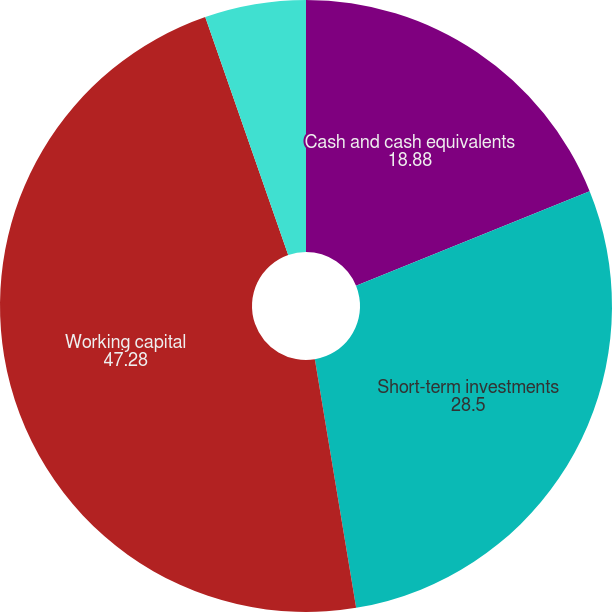Convert chart. <chart><loc_0><loc_0><loc_500><loc_500><pie_chart><fcel>Cash and cash equivalents<fcel>Short-term investments<fcel>Working capital<fcel>Property and equipment net<nl><fcel>18.88%<fcel>28.5%<fcel>47.28%<fcel>5.34%<nl></chart> 